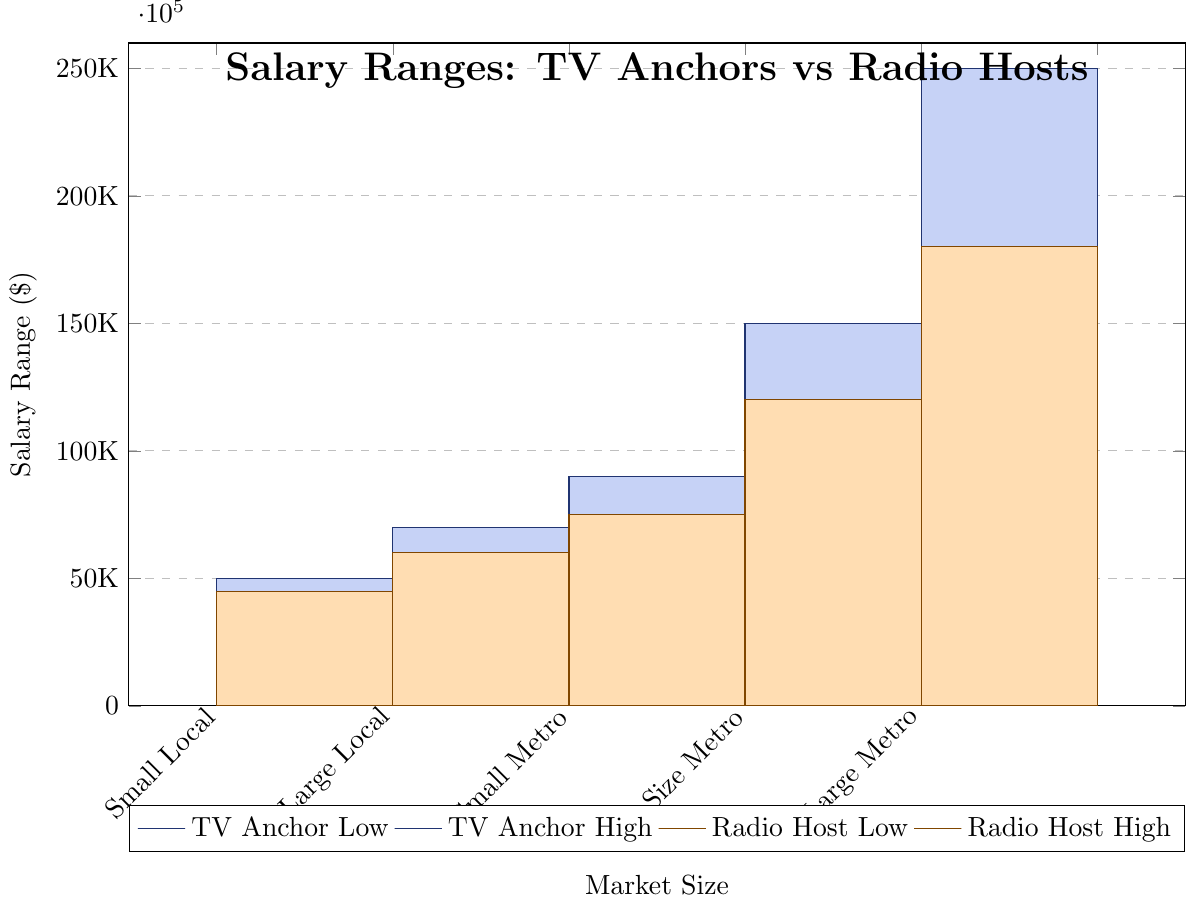what's the average high salary of a TV anchor in the Large Metro market and a Radio host in the same market? The high salary of a TV anchor in the Large Metro market is 250,000, and the high salary of a Radio host is 180,000. The average is calculated as (250,000 + 180,000) / 2 = 215,000
Answer: 215,000 Which market size shows the smallest range in salary for Radio hosts? To find the smallest range, subtract the low salary from the high salary for each market. Small Local has a range of 45000 - 22000 = 23000, Large Local has a range of 60000 - 28000 = 32000, Small Metro has a range of 75000 - 35000 = 40000, Mid-Size Metro has a range of 120000 - 45000 = 75000, and Large Metro has a range of 180000 - 65000 = 115000. The smallest range is in the Small Local market.
Answer: Small Local In which market does the high salary of TV anchors exceed the high salary of Radio hosts by more than 100,000? Compare the high salary of TV anchors and Radio hosts for each market. In Large Metro, the difference is 250,000 - 180,000 = 70,000; in Mid-Size Metro, the difference is 150,000 - 120,000 = 30,000; in Small Metro, the difference is 90,000 - 75,000 = 15,000; in Large Local, the difference is 70,000 - 60,000 = 10,000; and in Small Local, the difference is 50,000 - 45,000 = 5,000. No market exceeds by more than 100,000.
Answer: None Which market has the highest low salary for TV anchors? Look at the low salary bars for TV anchors. The highest low salary is in the Large Metro market with 85,000.
Answer: Large Metro How much higher is the high salary of a Radio host in a Mid-Size Metro market compared to a Small Metro market? The high salary for a Radio host in a Mid-Size Metro market is 120,000, and in a Small Metro market, it is 75,000. The difference is 120,000 - 75,000 = 45,000.
Answer: 45,000 Which market has the lowest low salary for Radio hosts? Look at the low salary bars for Radio hosts. The lowest low salary is in the Small Local market with 22,000.
Answer: Small Local 